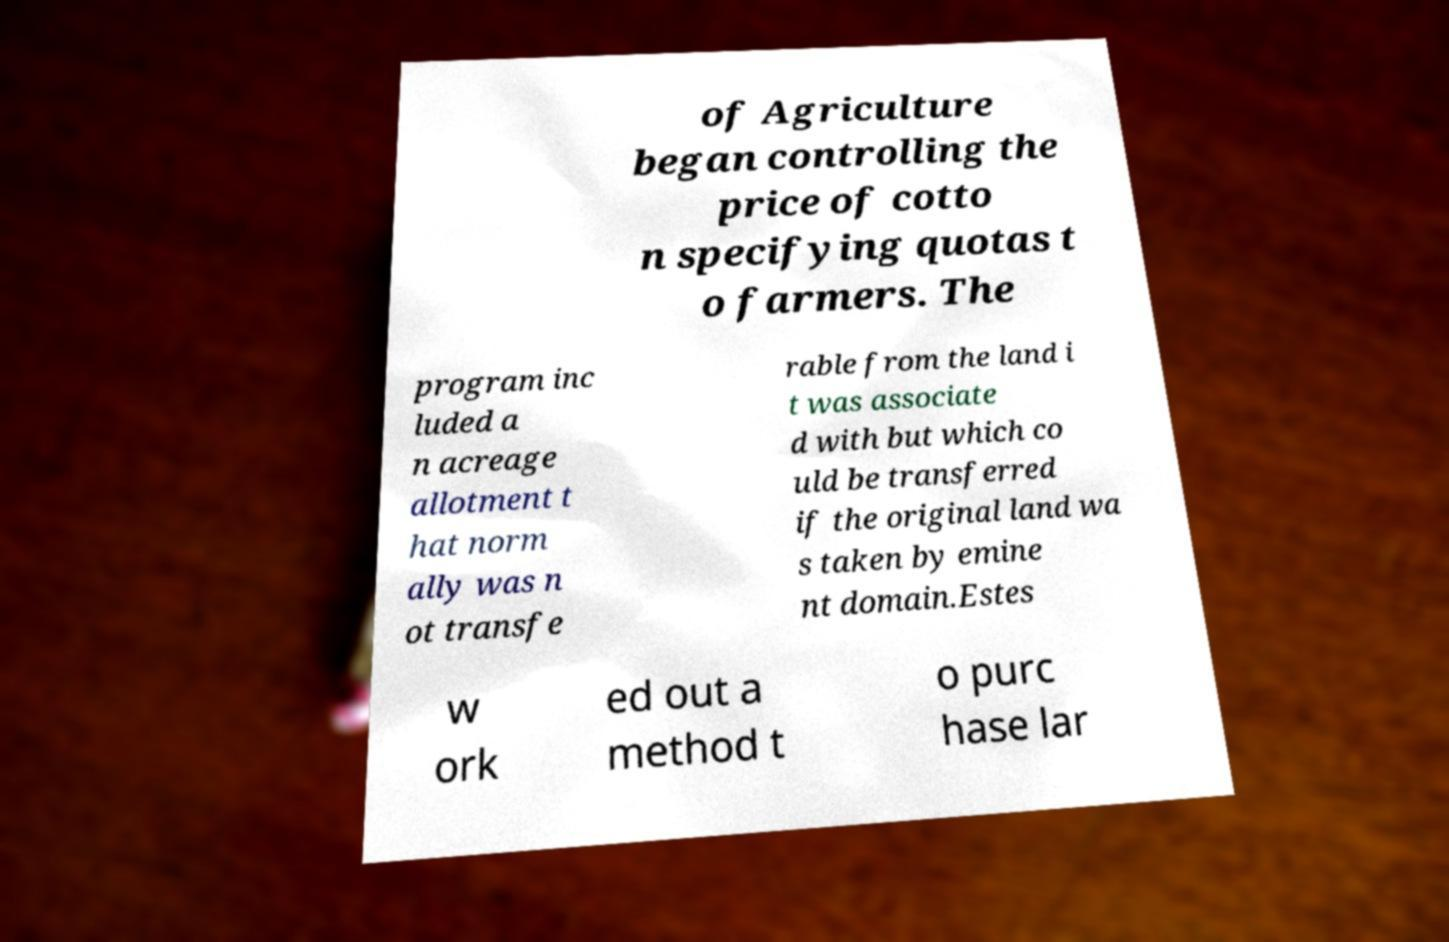Please identify and transcribe the text found in this image. of Agriculture began controlling the price of cotto n specifying quotas t o farmers. The program inc luded a n acreage allotment t hat norm ally was n ot transfe rable from the land i t was associate d with but which co uld be transferred if the original land wa s taken by emine nt domain.Estes w ork ed out a method t o purc hase lar 